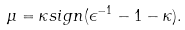<formula> <loc_0><loc_0><loc_500><loc_500>\mu = \kappa s i g n ( \epsilon ^ { - 1 } - 1 - \kappa ) .</formula> 